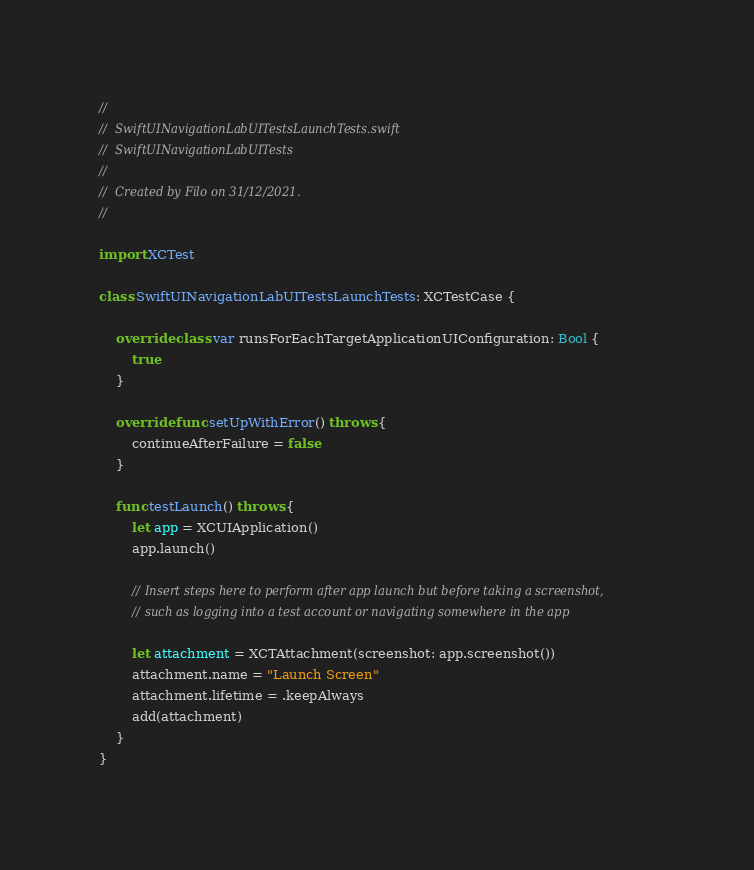<code> <loc_0><loc_0><loc_500><loc_500><_Swift_>//
//  SwiftUINavigationLabUITestsLaunchTests.swift
//  SwiftUINavigationLabUITests
//
//  Created by Filo on 31/12/2021.
//

import XCTest

class SwiftUINavigationLabUITestsLaunchTests: XCTestCase {

    override class var runsForEachTargetApplicationUIConfiguration: Bool {
        true
    }

    override func setUpWithError() throws {
        continueAfterFailure = false
    }

    func testLaunch() throws {
        let app = XCUIApplication()
        app.launch()

        // Insert steps here to perform after app launch but before taking a screenshot,
        // such as logging into a test account or navigating somewhere in the app

        let attachment = XCTAttachment(screenshot: app.screenshot())
        attachment.name = "Launch Screen"
        attachment.lifetime = .keepAlways
        add(attachment)
    }
}
</code> 